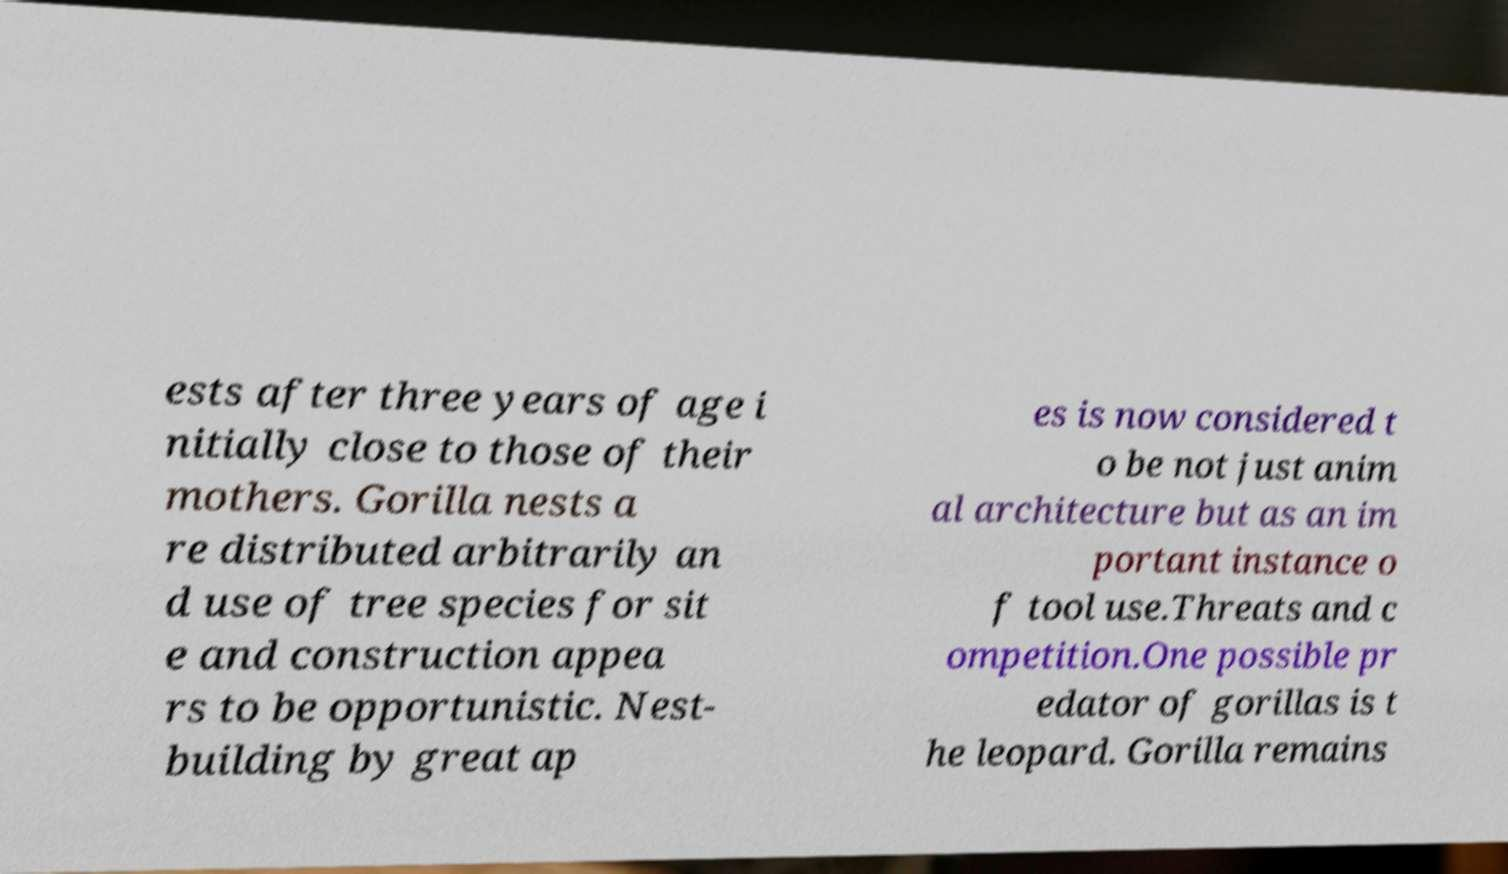Can you accurately transcribe the text from the provided image for me? ests after three years of age i nitially close to those of their mothers. Gorilla nests a re distributed arbitrarily an d use of tree species for sit e and construction appea rs to be opportunistic. Nest- building by great ap es is now considered t o be not just anim al architecture but as an im portant instance o f tool use.Threats and c ompetition.One possible pr edator of gorillas is t he leopard. Gorilla remains 